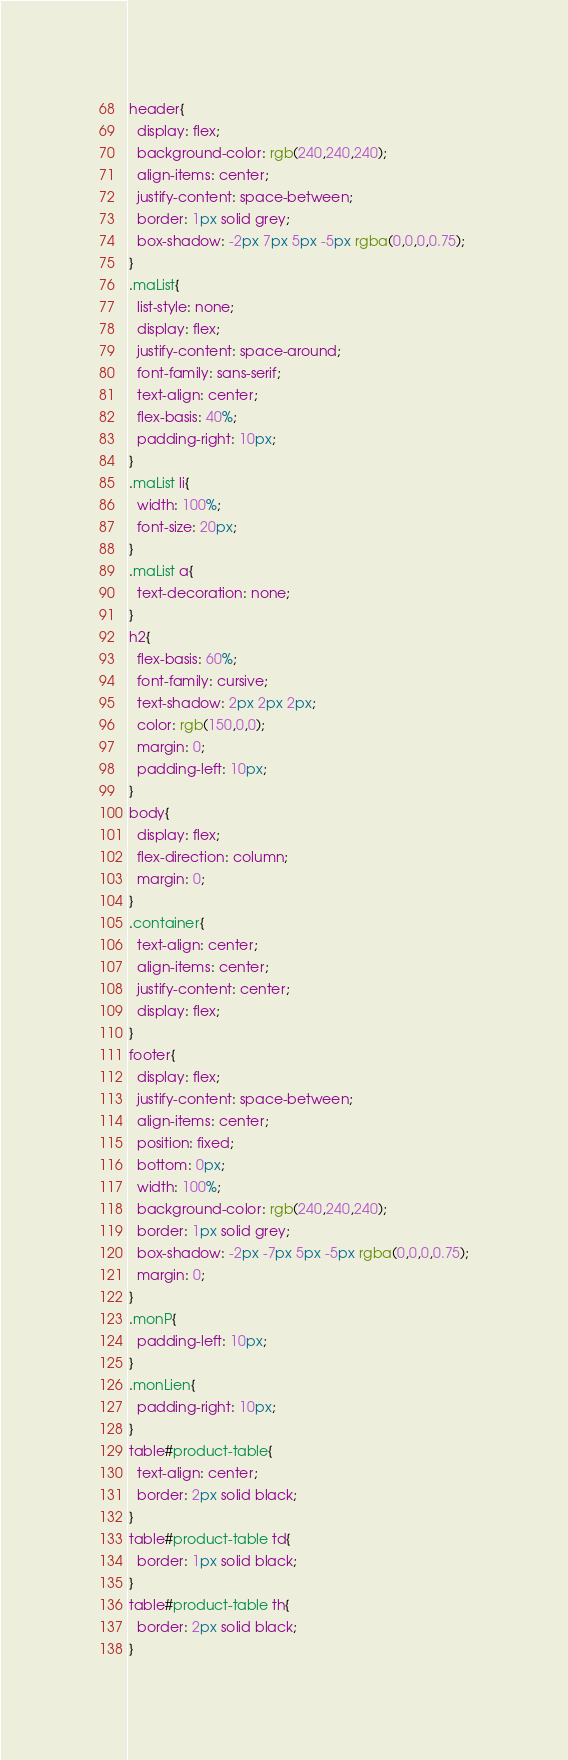<code> <loc_0><loc_0><loc_500><loc_500><_CSS_>header{
  display: flex;
  background-color: rgb(240,240,240);
  align-items: center;
  justify-content: space-between;
  border: 1px solid grey;
  box-shadow: -2px 7px 5px -5px rgba(0,0,0,0.75);
}
.maList{
  list-style: none;
  display: flex;
  justify-content: space-around;
  font-family: sans-serif;
  text-align: center;
  flex-basis: 40%;
  padding-right: 10px;
}
.maList li{
  width: 100%;
  font-size: 20px;
}
.maList a{
  text-decoration: none;
}
h2{
  flex-basis: 60%;
  font-family: cursive;
  text-shadow: 2px 2px 2px;
  color: rgb(150,0,0);
  margin: 0;
  padding-left: 10px;
}
body{
  display: flex;
  flex-direction: column;
  margin: 0;
}
.container{
  text-align: center;
  align-items: center;
  justify-content: center;
  display: flex;
}
footer{
  display: flex;
  justify-content: space-between;
  align-items: center;
  position: fixed;
  bottom: 0px;
  width: 100%;
  background-color: rgb(240,240,240);
  border: 1px solid grey;
  box-shadow: -2px -7px 5px -5px rgba(0,0,0,0.75);
  margin: 0;
}
.monP{
  padding-left: 10px;
}
.monLien{
  padding-right: 10px;
}
table#product-table{
  text-align: center;
  border: 2px solid black;
}
table#product-table td{
  border: 1px solid black;
}
table#product-table th{
  border: 2px solid black;
}
</code> 